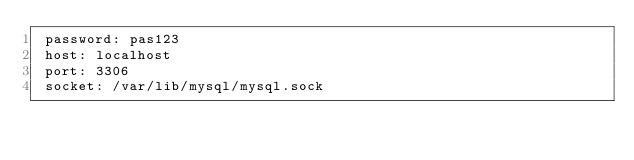Convert code to text. <code><loc_0><loc_0><loc_500><loc_500><_YAML_> password: pas123
 host: localhost
 port: 3306
 socket: /var/lib/mysql/mysql.sock
</code> 